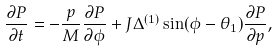Convert formula to latex. <formula><loc_0><loc_0><loc_500><loc_500>\frac { \partial P } { \partial t } = - \frac { p } { M } \frac { \partial P } { \partial \phi } + J \Delta ^ { ( 1 ) } \sin ( \phi - \theta _ { 1 } ) \frac { \partial P } { \partial p } ,</formula> 